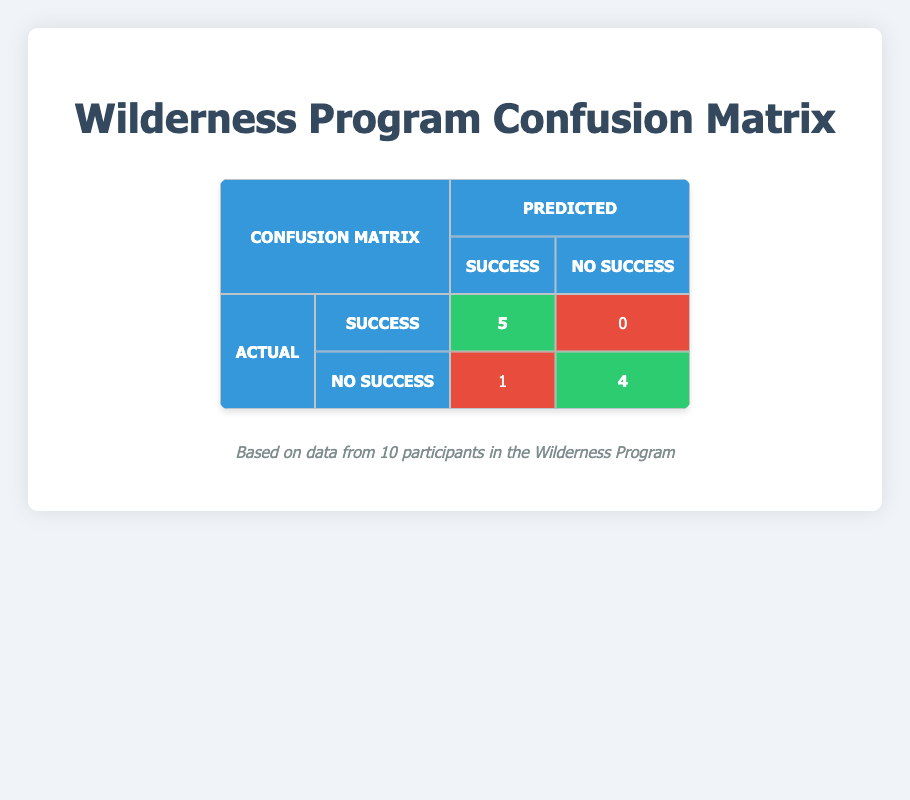What is the total number of participants who successfully completed the program? The table shows that there are 5 successful completions (highlighted in green) and 1 failure. Therefore, the total count of successful completions is directly read from the first row of the table, which indicates that the completed and successful count is 5.
Answer: 5 How many participants were predicted to not succeed but actually succeeded? The confusion matrix indicates that there were 0 participants who were predicted to be in the "No Success" group but actually succeeded. Therefore, this information is directly taken from the first row, where the value (0) is clear.
Answer: 0 What is the total count of participants who did not succeed in the program? In the matrix, under "Actual No Success," there are 4 participants who did not succeed (highlighted in red). This value can be directly obtained from the second row of the table.
Answer: 4 What percentage of participants actually succeeded in the program? To calculate the percentage of participants who succeeded in the program, we sum the successful counts: 5 (success) out of a total of 10 participants. Therefore, the percentage of success is (5/10) * 100 = 50%.
Answer: 50% Is it true that more participants succeeded in the program than those who did not? We can compare the number of successful participants (5) against those who did not succeed (4) as shown in the confusion matrix. Since 5 is greater than 4, this statement is true.
Answer: Yes What is the ratio of participants that succeeded to those who did not succeed? The number of participants who succeeded is 5, and those who did not succeed is 4. Therefore, the ratio is 5 to 4, or 5:4 when simplified.
Answer: 5:4 How many participants dropped out of the program after not succeeding? From the enrollment outcomes, 1 participant was marked as "Dropped Out" while not succeeding; that participant is clearly identified in the earlier data. Therefore, this value can be directly identified as 1 based on no-success outcomes.
Answer: 1 What is the total number of participants who are in progress? By examining the table, we can see that there are 2 participants in progress without any completions; they are clearly identified, and the total count amounts to 2.
Answer: 2 What is the comparison of success rates between male and female participants? Here we can gather that males successfully completed the program 3 times, while females had 2 successful completions. Comparing these numbers, we see there are more male successes. To find the rates, (males: 3 out of 5, females: 2 out of 5) show a comparative success rate favoring males.
Answer: Males had a higher success rate 